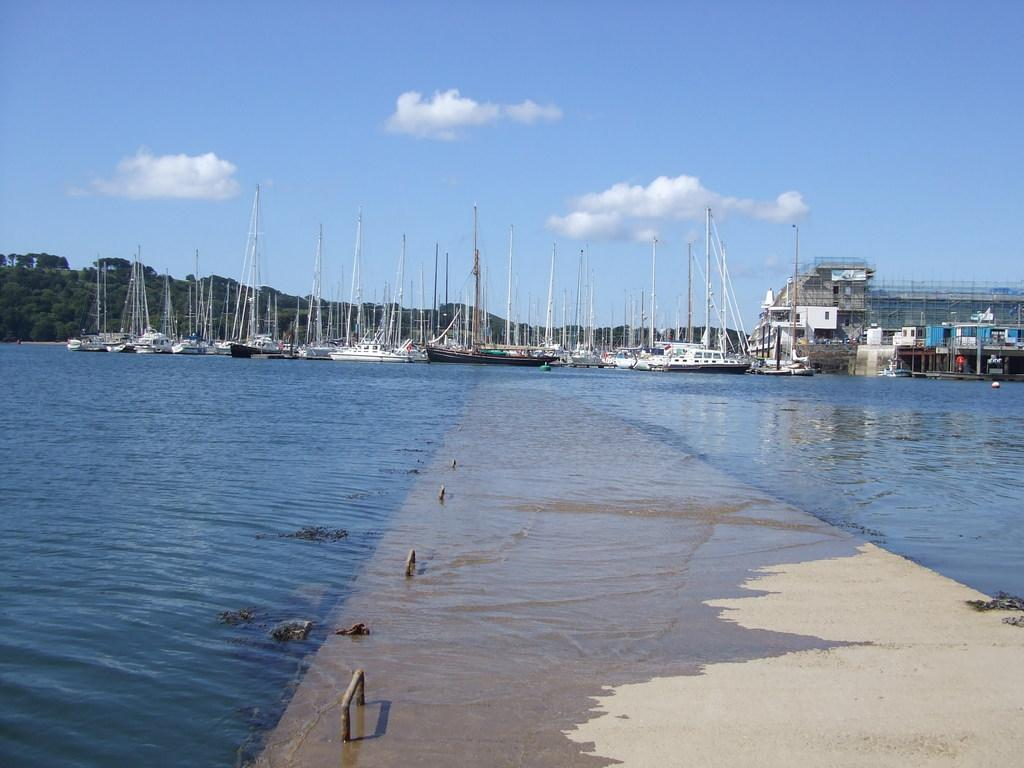What is the primary element visible in the image? There is water in the image. What can be seen in the background of the image? There are boats, trees, a building, and the sky visible in the background of the image. What is the condition of the sky in the image? The sky is visible in the background of the image, and there are clouds present. What type of wristwatch is the person wearing in the image? There is no person visible in the image, and therefore no wristwatch can be observed. What is the person feeling ashamed about in the image? There is no person visible in the image, and therefore no emotion, such as shame, can be attributed to anyone. 